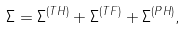Convert formula to latex. <formula><loc_0><loc_0><loc_500><loc_500>\Sigma = \Sigma ^ { ( T H ) } + \Sigma ^ { ( T F ) } + \Sigma ^ { ( P H ) } ,</formula> 